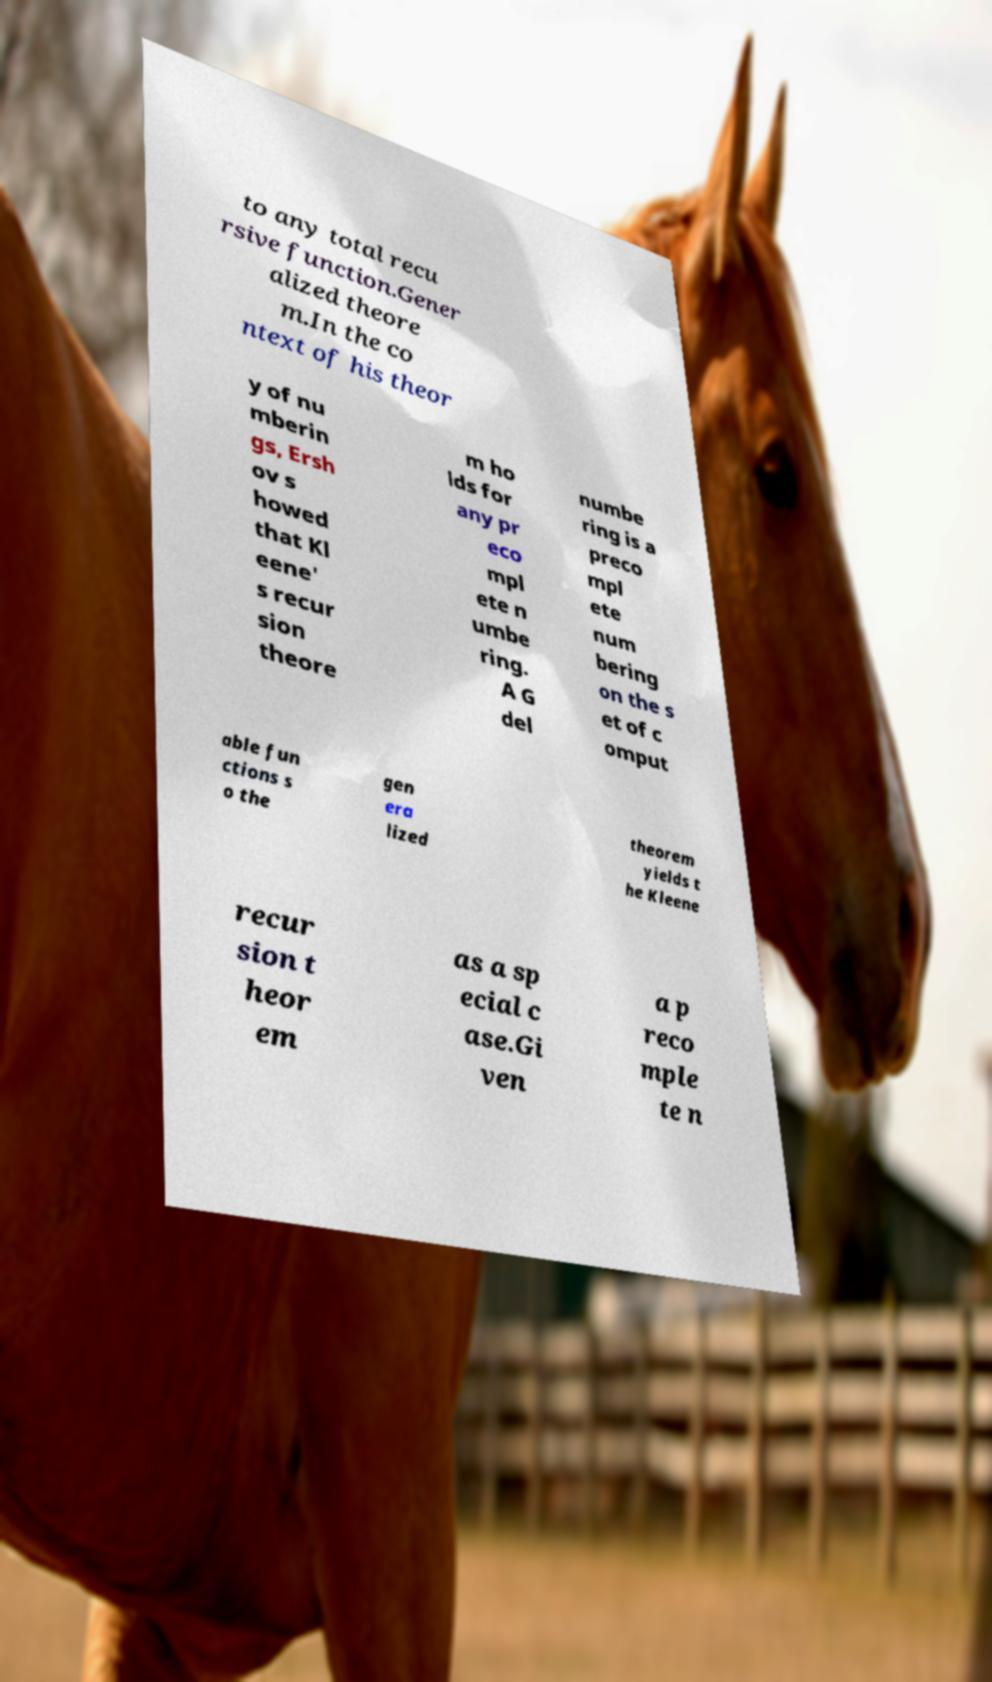Could you extract and type out the text from this image? to any total recu rsive function.Gener alized theore m.In the co ntext of his theor y of nu mberin gs, Ersh ov s howed that Kl eene' s recur sion theore m ho lds for any pr eco mpl ete n umbe ring. A G del numbe ring is a preco mpl ete num bering on the s et of c omput able fun ctions s o the gen era lized theorem yields t he Kleene recur sion t heor em as a sp ecial c ase.Gi ven a p reco mple te n 